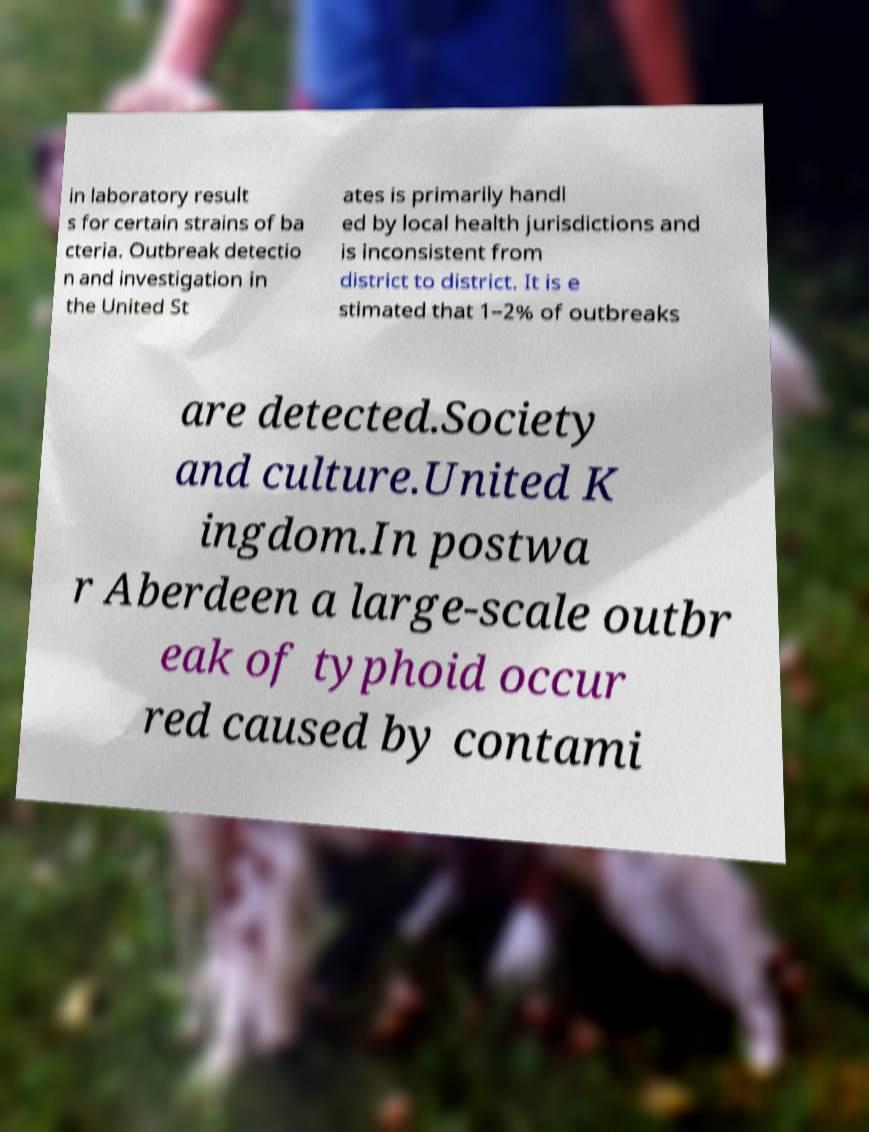I need the written content from this picture converted into text. Can you do that? in laboratory result s for certain strains of ba cteria. Outbreak detectio n and investigation in the United St ates is primarily handl ed by local health jurisdictions and is inconsistent from district to district. It is e stimated that 1–2% of outbreaks are detected.Society and culture.United K ingdom.In postwa r Aberdeen a large-scale outbr eak of typhoid occur red caused by contami 